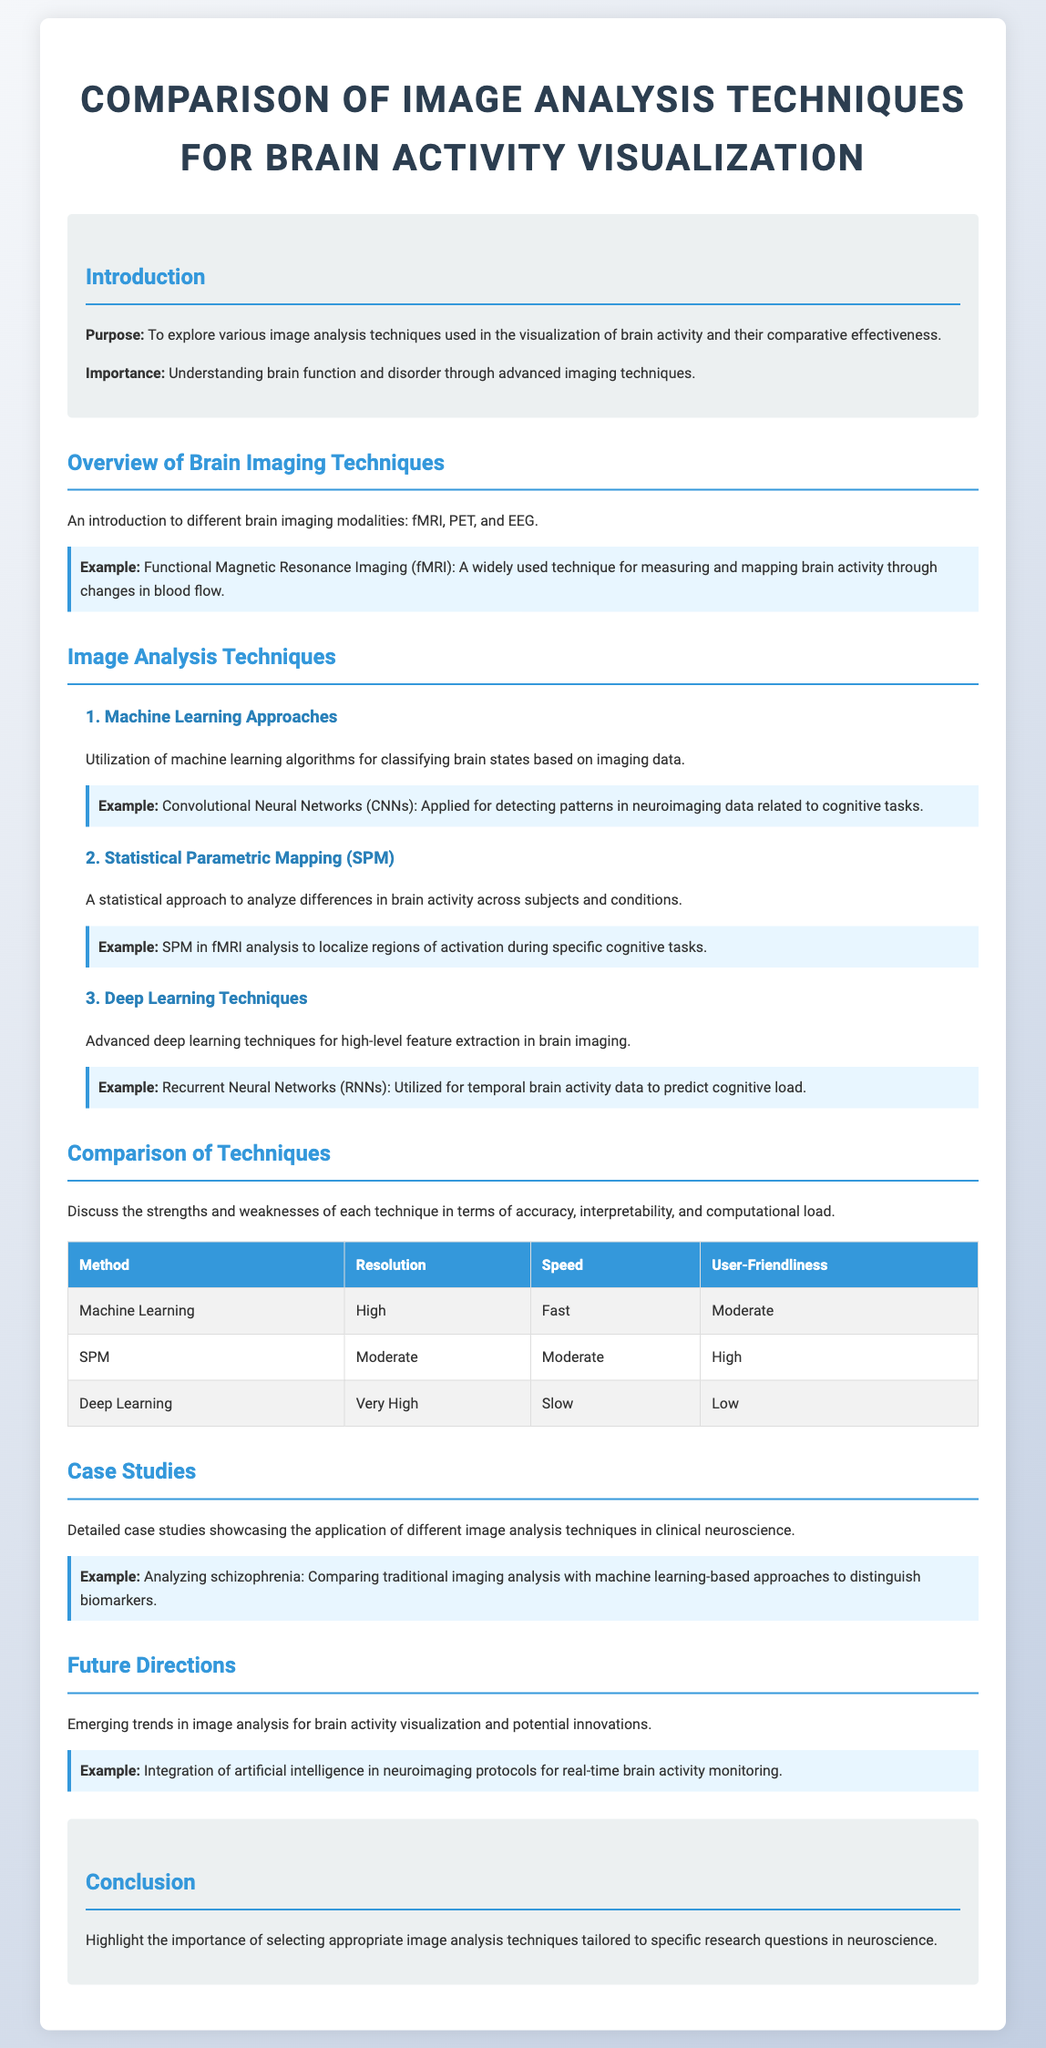What is the purpose of the document? The purpose is stated in the introduction as exploring various image analysis techniques used in the visualization of brain activity and their comparative effectiveness.
Answer: To explore various image analysis techniques used in the visualization of brain activity and their comparative effectiveness What technique is widely used for measuring brain activity? The document describes Functional Magnetic Resonance Imaging as a widely used technique for measuring and mapping brain activity through changes in blood flow.
Answer: Functional Magnetic Resonance Imaging (fMRI) Which image analysis technique offers very high resolution? The comparison table lists Deep Learning as the method with very high resolution.
Answer: Deep Learning What is one example of a machine learning approach mentioned? The document provides Convolutional Neural Networks as an example of a machine learning approach applied for detecting patterns in neuroimaging data.
Answer: Convolutional Neural Networks (CNNs) What is one of the strengths of Statistical Parametric Mapping? The comparison table indicates that one of the strengths of SPM is its user-friendliness rated as high.
Answer: High Which case study involves analyzing schizophrenia? The document mentions comparing traditional imaging analysis with machine learning-based approaches to distinguish biomarkers in schizophrenia as an example of a case study.
Answer: Comparing traditional imaging analysis with machine learning-based approaches What is a future direction in image analysis for brain activity visualization? The document lists the integration of artificial intelligence in neuroimaging protocols for real-time brain activity monitoring as a future direction.
Answer: Integration of artificial intelligence What is the computational load of machine learning approaches? The comparison table states that the computational load for machine learning is moderate.
Answer: Moderate 